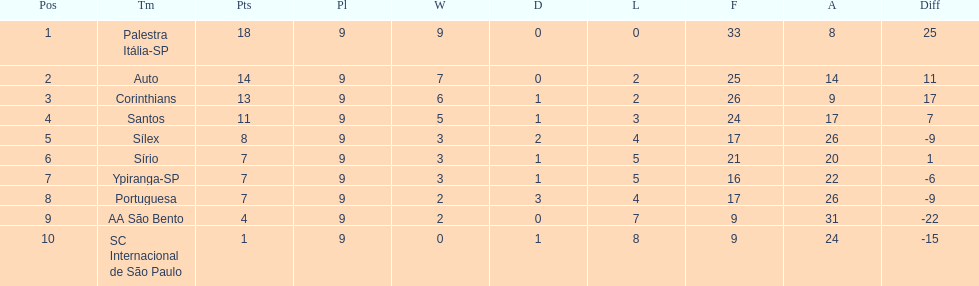In 1926 brazilian football,what was the total number of points scored? 90. 